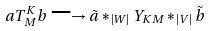<formula> <loc_0><loc_0><loc_500><loc_500>a T _ { M } ^ { K } b \longrightarrow \tilde { a } * _ { | W | } Y _ { K M } * _ { | V | } \tilde { b }</formula> 